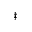Convert formula to latex. <formula><loc_0><loc_0><loc_500><loc_500>^ { \ddagger }</formula> 